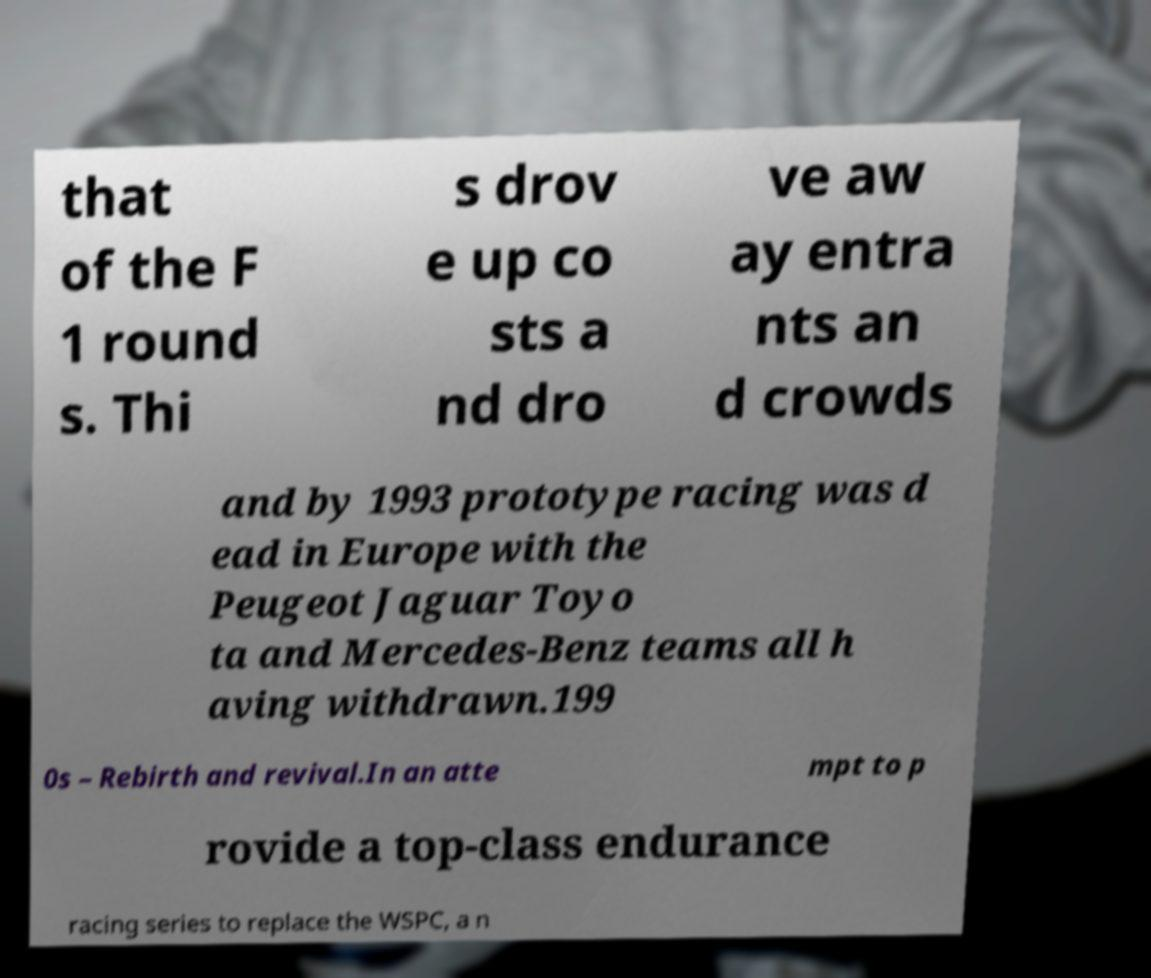Can you accurately transcribe the text from the provided image for me? that of the F 1 round s. Thi s drov e up co sts a nd dro ve aw ay entra nts an d crowds and by 1993 prototype racing was d ead in Europe with the Peugeot Jaguar Toyo ta and Mercedes-Benz teams all h aving withdrawn.199 0s – Rebirth and revival.In an atte mpt to p rovide a top-class endurance racing series to replace the WSPC, a n 